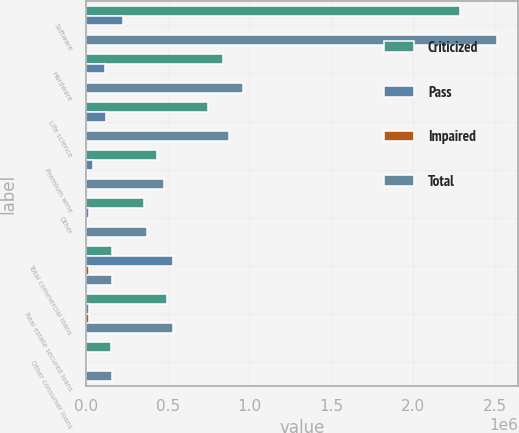<chart> <loc_0><loc_0><loc_500><loc_500><stacked_bar_chart><ecel><fcel>Software<fcel>Hardware<fcel>Life science<fcel>Premium wine<fcel>Other<fcel>Total commercial loans<fcel>Real estate secured loans<fcel>Other consumer loans<nl><fcel>Criticized<fcel>2.2905e+06<fcel>839230<fcel>748129<fcel>434309<fcel>353434<fcel>156106<fcel>497060<fcel>151101<nl><fcel>Pass<fcel>226251<fcel>117456<fcel>123973<fcel>41272<fcel>17120<fcel>534219<fcel>18474<fcel>6878<nl><fcel>Impaired<fcel>1142<fcel>5183<fcel>311<fcel>3212<fcel>5353<fcel>15201<fcel>18283<fcel>3133<nl><fcel>Total<fcel>2.51789e+06<fcel>961869<fcel>872413<fcel>478793<fcel>375907<fcel>156106<fcel>533817<fcel>161112<nl></chart> 